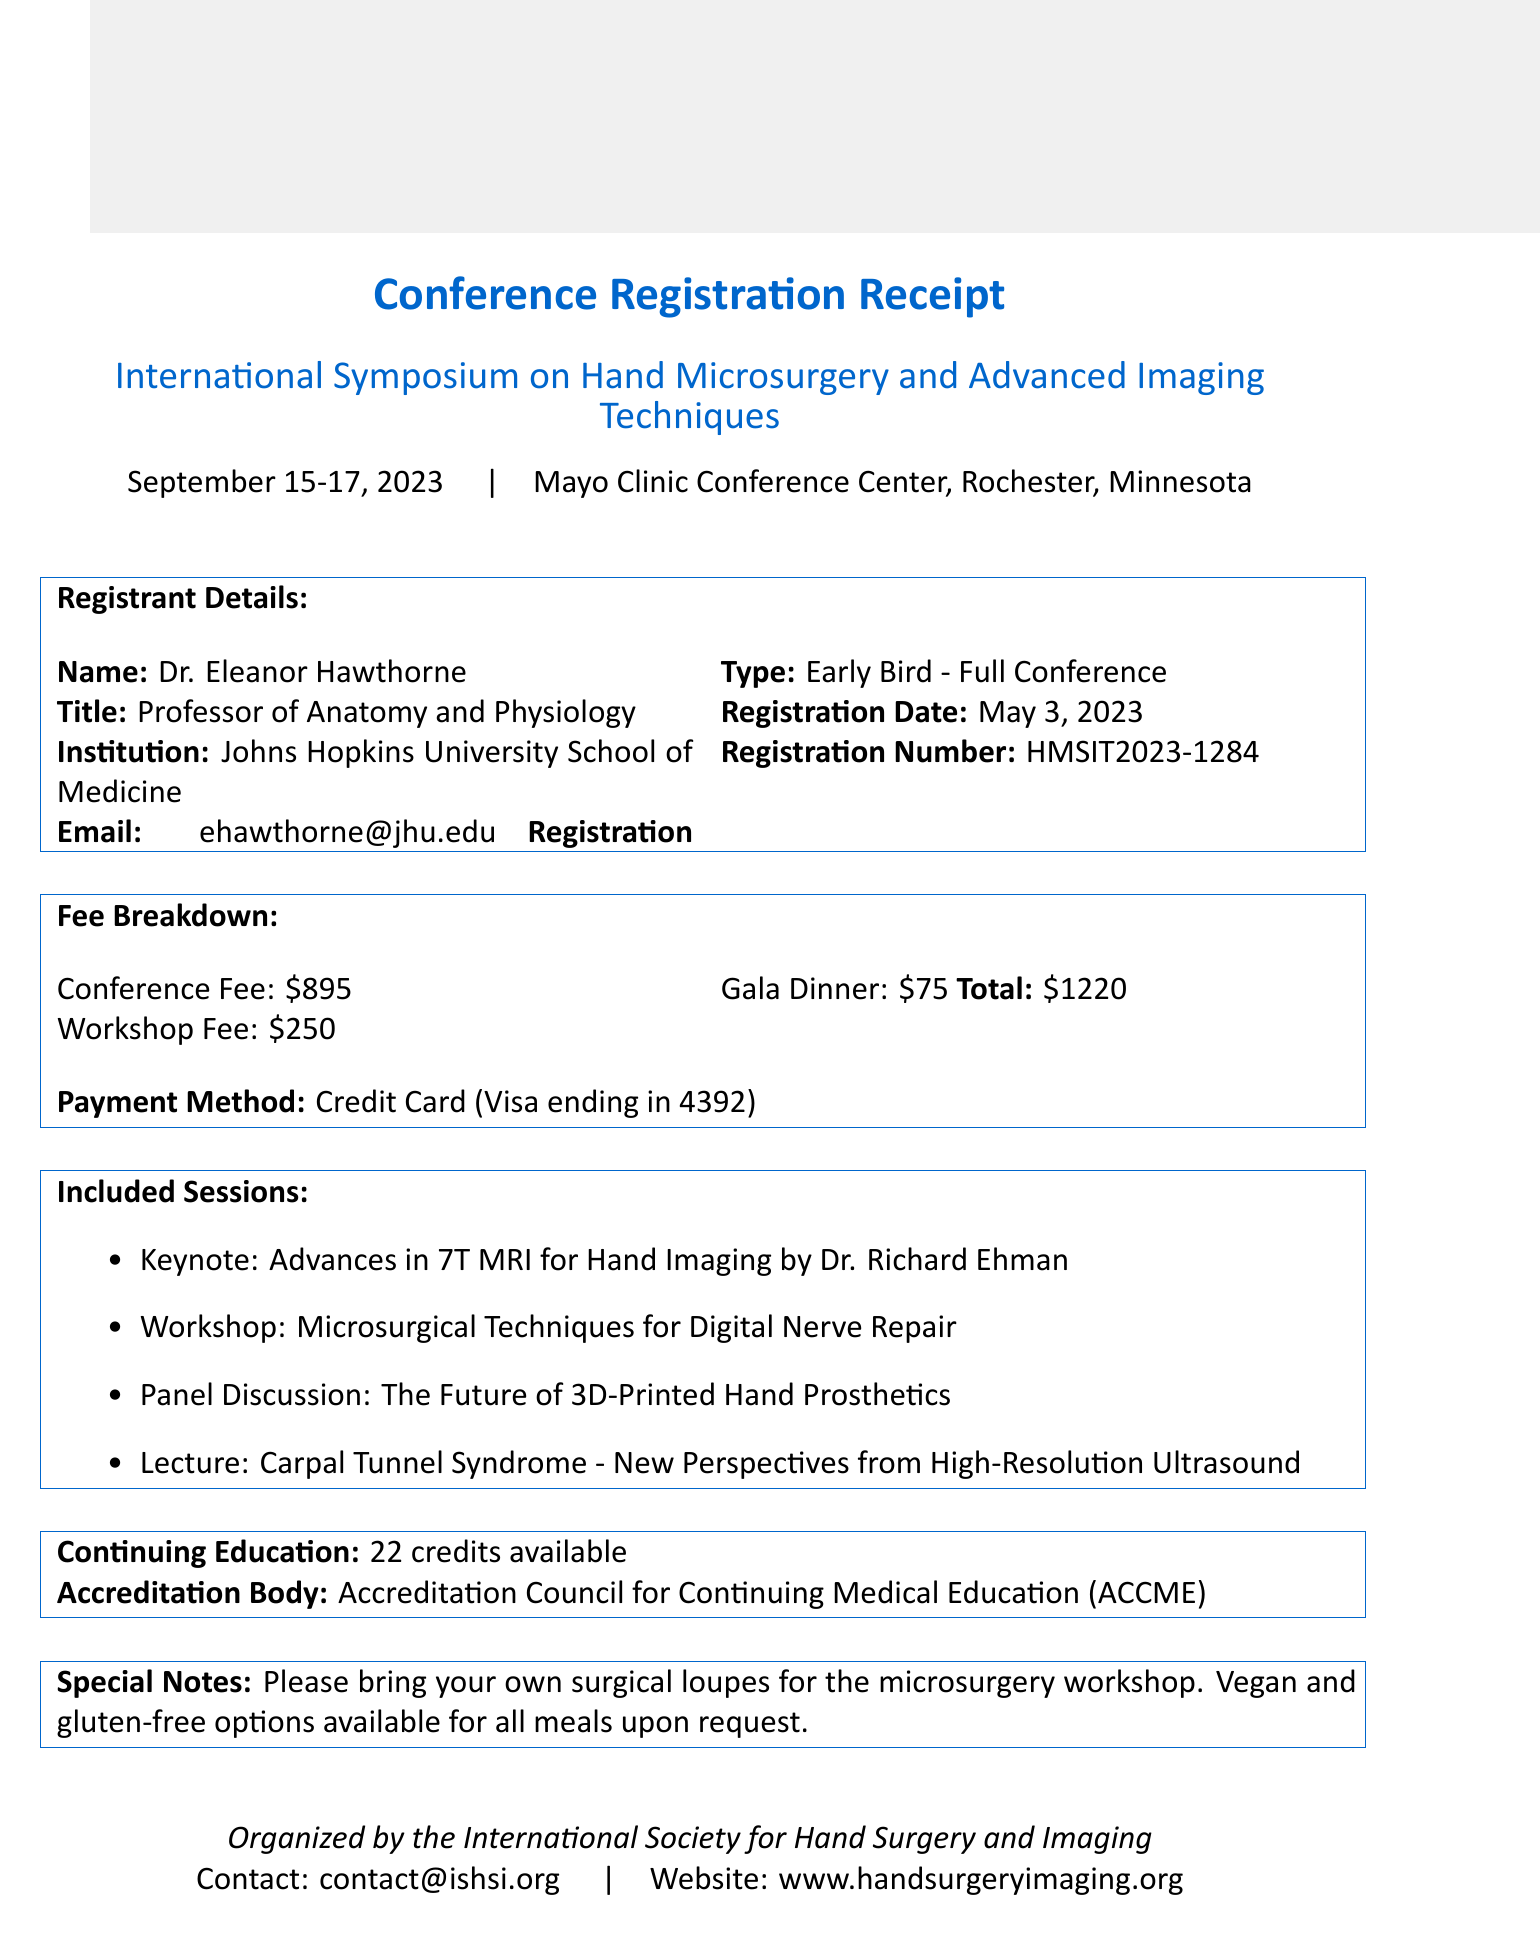What is the event name? The event name is provided at the beginning of the document, which is the main focus of the receipt.
Answer: International Symposium on Hand Microsurgery and Advanced Imaging Techniques Who is the registrant? The registrant's name is stated under the registrant details section of the document.
Answer: Dr. Eleanor Hawthorne What is the registration number? The registration number is given in the registration details section and is a unique identifier for the registrant.
Answer: HMSIT2023-1284 What are the total fees? The total fees are the sum of the conference fee, workshop fee, and gala dinner, clearly outlined in the fee breakdown section of the document.
Answer: $1220 How many continuing education credits are available? The number of continuing education credits is specified in the continuing education section of the document.
Answer: 22 What payment method was used? The payment method is listed in the fee breakdown section of the receipt, indicating how the registrant paid.
Answer: Credit Card (Visa ending in 4392) What session covers digital nerve repair? The session related to digital nerve repair is specified in the included sessions section.
Answer: Workshop: Microsurgical Techniques for Digital Nerve Repair What special item should attendees bring? The special note provides important guidance on what attendees need to bring for one of the workshops.
Answer: Surgical loupes Who organized the event? The organizer's name is included at the bottom of the document and highlights the organizing body for the symposium.
Answer: International Society for Hand Surgery and Imaging 